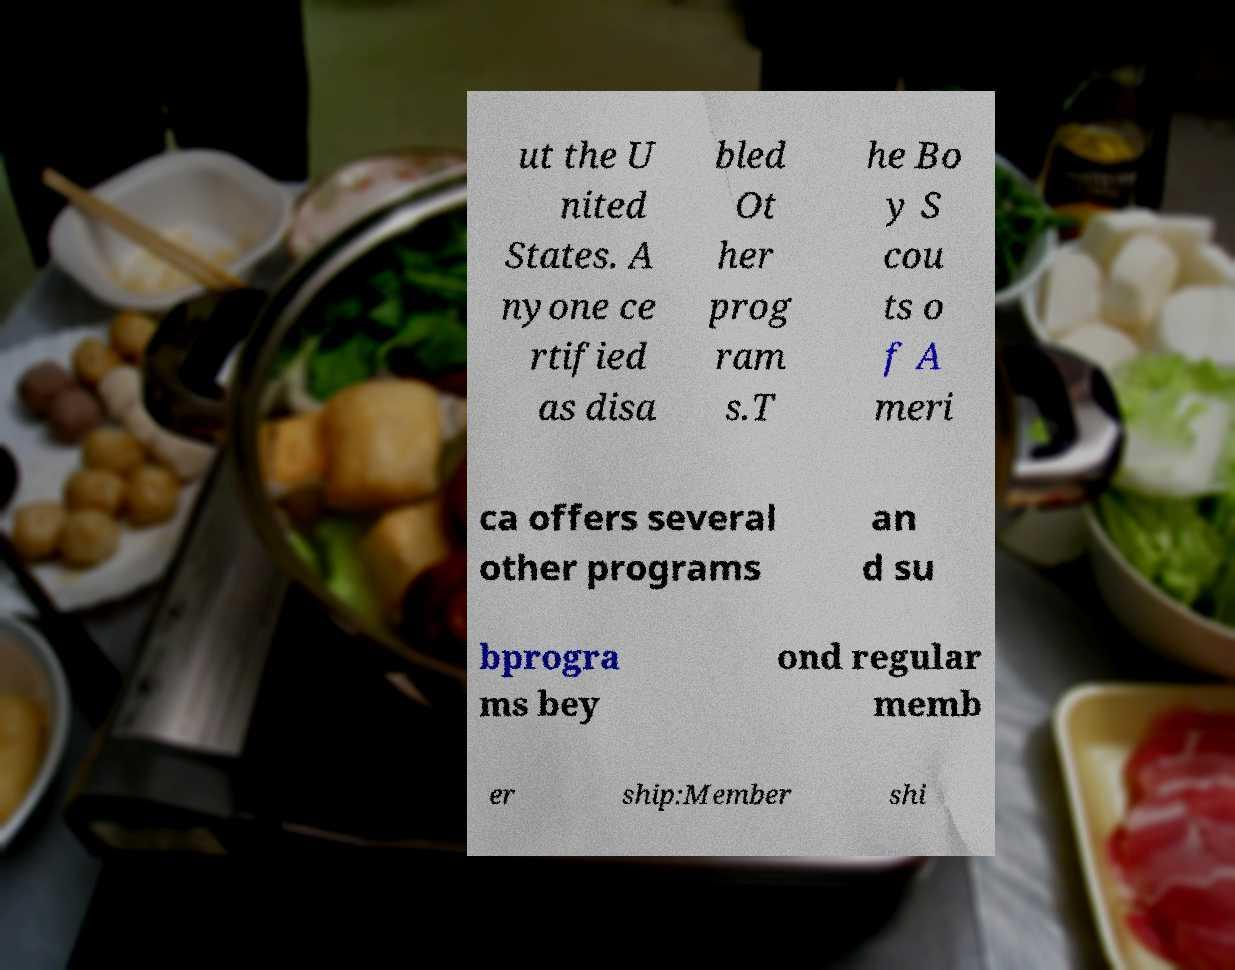Could you extract and type out the text from this image? ut the U nited States. A nyone ce rtified as disa bled Ot her prog ram s.T he Bo y S cou ts o f A meri ca offers several other programs an d su bprogra ms bey ond regular memb er ship:Member shi 